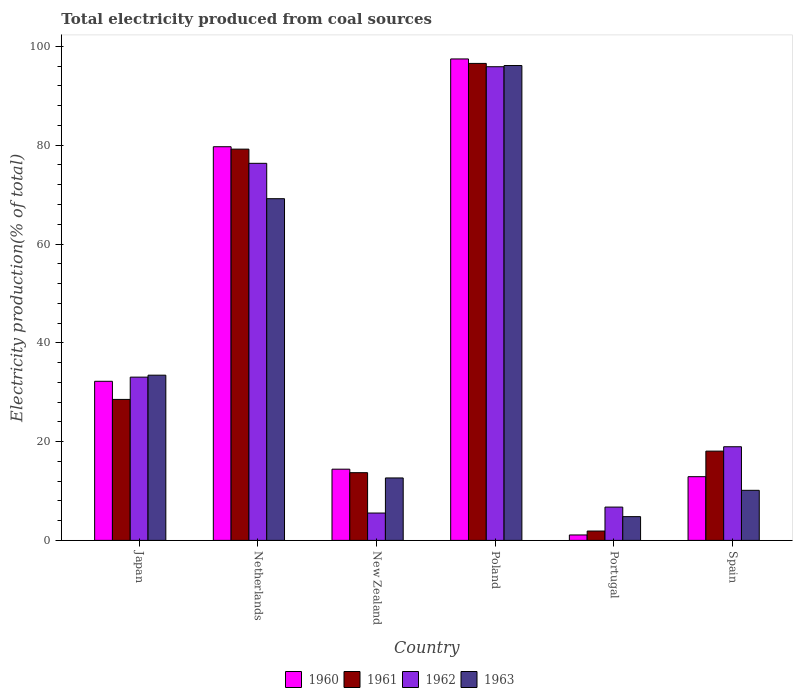How many groups of bars are there?
Offer a terse response. 6. Are the number of bars per tick equal to the number of legend labels?
Offer a terse response. Yes. What is the label of the 3rd group of bars from the left?
Make the answer very short. New Zealand. What is the total electricity produced in 1963 in Netherlands?
Provide a short and direct response. 69.17. Across all countries, what is the maximum total electricity produced in 1962?
Your response must be concise. 95.89. Across all countries, what is the minimum total electricity produced in 1960?
Ensure brevity in your answer.  1.1. In which country was the total electricity produced in 1961 maximum?
Offer a terse response. Poland. What is the total total electricity produced in 1962 in the graph?
Ensure brevity in your answer.  236.5. What is the difference between the total electricity produced in 1963 in Japan and that in Portugal?
Provide a short and direct response. 28.63. What is the difference between the total electricity produced in 1960 in Portugal and the total electricity produced in 1961 in Netherlands?
Provide a short and direct response. -78.11. What is the average total electricity produced in 1961 per country?
Provide a short and direct response. 39.66. What is the difference between the total electricity produced of/in 1962 and total electricity produced of/in 1963 in Portugal?
Make the answer very short. 1.93. What is the ratio of the total electricity produced in 1960 in Netherlands to that in Portugal?
Ensure brevity in your answer.  72.59. Is the difference between the total electricity produced in 1962 in Netherlands and Poland greater than the difference between the total electricity produced in 1963 in Netherlands and Poland?
Offer a very short reply. Yes. What is the difference between the highest and the second highest total electricity produced in 1963?
Offer a terse response. 62.69. What is the difference between the highest and the lowest total electricity produced in 1963?
Give a very brief answer. 91.32. Is the sum of the total electricity produced in 1961 in Portugal and Spain greater than the maximum total electricity produced in 1963 across all countries?
Offer a very short reply. No. What does the 1st bar from the left in Japan represents?
Make the answer very short. 1960. What does the 1st bar from the right in Netherlands represents?
Provide a short and direct response. 1963. Is it the case that in every country, the sum of the total electricity produced in 1963 and total electricity produced in 1960 is greater than the total electricity produced in 1962?
Provide a short and direct response. No. How many bars are there?
Provide a succinct answer. 24. Are all the bars in the graph horizontal?
Make the answer very short. No. What is the difference between two consecutive major ticks on the Y-axis?
Offer a very short reply. 20. Are the values on the major ticks of Y-axis written in scientific E-notation?
Give a very brief answer. No. Does the graph contain any zero values?
Provide a succinct answer. No. Does the graph contain grids?
Make the answer very short. No. How many legend labels are there?
Give a very brief answer. 4. How are the legend labels stacked?
Keep it short and to the point. Horizontal. What is the title of the graph?
Provide a short and direct response. Total electricity produced from coal sources. Does "1990" appear as one of the legend labels in the graph?
Ensure brevity in your answer.  No. What is the label or title of the X-axis?
Ensure brevity in your answer.  Country. What is the label or title of the Y-axis?
Your answer should be very brief. Electricity production(% of total). What is the Electricity production(% of total) in 1960 in Japan?
Offer a terse response. 32.21. What is the Electricity production(% of total) in 1961 in Japan?
Your answer should be compact. 28.54. What is the Electricity production(% of total) in 1962 in Japan?
Your response must be concise. 33.05. What is the Electricity production(% of total) in 1963 in Japan?
Give a very brief answer. 33.44. What is the Electricity production(% of total) in 1960 in Netherlands?
Keep it short and to the point. 79.69. What is the Electricity production(% of total) of 1961 in Netherlands?
Provide a short and direct response. 79.2. What is the Electricity production(% of total) of 1962 in Netherlands?
Offer a very short reply. 76.33. What is the Electricity production(% of total) of 1963 in Netherlands?
Provide a short and direct response. 69.17. What is the Electricity production(% of total) in 1960 in New Zealand?
Ensure brevity in your answer.  14.42. What is the Electricity production(% of total) in 1961 in New Zealand?
Your response must be concise. 13.71. What is the Electricity production(% of total) in 1962 in New Zealand?
Ensure brevity in your answer.  5.54. What is the Electricity production(% of total) in 1963 in New Zealand?
Keep it short and to the point. 12.64. What is the Electricity production(% of total) of 1960 in Poland?
Provide a short and direct response. 97.46. What is the Electricity production(% of total) in 1961 in Poland?
Offer a very short reply. 96.56. What is the Electricity production(% of total) of 1962 in Poland?
Ensure brevity in your answer.  95.89. What is the Electricity production(% of total) in 1963 in Poland?
Give a very brief answer. 96.13. What is the Electricity production(% of total) in 1960 in Portugal?
Keep it short and to the point. 1.1. What is the Electricity production(% of total) in 1961 in Portugal?
Provide a short and direct response. 1.89. What is the Electricity production(% of total) in 1962 in Portugal?
Ensure brevity in your answer.  6.74. What is the Electricity production(% of total) of 1963 in Portugal?
Make the answer very short. 4.81. What is the Electricity production(% of total) in 1960 in Spain?
Offer a terse response. 12.9. What is the Electricity production(% of total) of 1961 in Spain?
Your answer should be compact. 18.07. What is the Electricity production(% of total) in 1962 in Spain?
Provide a succinct answer. 18.96. What is the Electricity production(% of total) in 1963 in Spain?
Make the answer very short. 10.14. Across all countries, what is the maximum Electricity production(% of total) of 1960?
Your answer should be very brief. 97.46. Across all countries, what is the maximum Electricity production(% of total) in 1961?
Provide a succinct answer. 96.56. Across all countries, what is the maximum Electricity production(% of total) of 1962?
Keep it short and to the point. 95.89. Across all countries, what is the maximum Electricity production(% of total) in 1963?
Keep it short and to the point. 96.13. Across all countries, what is the minimum Electricity production(% of total) of 1960?
Your response must be concise. 1.1. Across all countries, what is the minimum Electricity production(% of total) in 1961?
Your answer should be compact. 1.89. Across all countries, what is the minimum Electricity production(% of total) in 1962?
Your response must be concise. 5.54. Across all countries, what is the minimum Electricity production(% of total) of 1963?
Keep it short and to the point. 4.81. What is the total Electricity production(% of total) in 1960 in the graph?
Ensure brevity in your answer.  237.78. What is the total Electricity production(% of total) of 1961 in the graph?
Your answer should be very brief. 237.98. What is the total Electricity production(% of total) of 1962 in the graph?
Keep it short and to the point. 236.5. What is the total Electricity production(% of total) in 1963 in the graph?
Your response must be concise. 226.33. What is the difference between the Electricity production(% of total) of 1960 in Japan and that in Netherlands?
Provide a short and direct response. -47.48. What is the difference between the Electricity production(% of total) in 1961 in Japan and that in Netherlands?
Your response must be concise. -50.67. What is the difference between the Electricity production(% of total) in 1962 in Japan and that in Netherlands?
Ensure brevity in your answer.  -43.28. What is the difference between the Electricity production(% of total) in 1963 in Japan and that in Netherlands?
Offer a terse response. -35.73. What is the difference between the Electricity production(% of total) of 1960 in Japan and that in New Zealand?
Provide a short and direct response. 17.79. What is the difference between the Electricity production(% of total) of 1961 in Japan and that in New Zealand?
Ensure brevity in your answer.  14.83. What is the difference between the Electricity production(% of total) in 1962 in Japan and that in New Zealand?
Offer a very short reply. 27.51. What is the difference between the Electricity production(% of total) of 1963 in Japan and that in New Zealand?
Your answer should be compact. 20.8. What is the difference between the Electricity production(% of total) in 1960 in Japan and that in Poland?
Your response must be concise. -65.25. What is the difference between the Electricity production(% of total) of 1961 in Japan and that in Poland?
Your response must be concise. -68.02. What is the difference between the Electricity production(% of total) of 1962 in Japan and that in Poland?
Your answer should be very brief. -62.84. What is the difference between the Electricity production(% of total) of 1963 in Japan and that in Poland?
Your response must be concise. -62.69. What is the difference between the Electricity production(% of total) of 1960 in Japan and that in Portugal?
Provide a short and direct response. 31.11. What is the difference between the Electricity production(% of total) of 1961 in Japan and that in Portugal?
Your answer should be compact. 26.64. What is the difference between the Electricity production(% of total) in 1962 in Japan and that in Portugal?
Give a very brief answer. 26.31. What is the difference between the Electricity production(% of total) of 1963 in Japan and that in Portugal?
Your answer should be very brief. 28.63. What is the difference between the Electricity production(% of total) of 1960 in Japan and that in Spain?
Give a very brief answer. 19.31. What is the difference between the Electricity production(% of total) in 1961 in Japan and that in Spain?
Ensure brevity in your answer.  10.47. What is the difference between the Electricity production(% of total) in 1962 in Japan and that in Spain?
Provide a short and direct response. 14.09. What is the difference between the Electricity production(% of total) of 1963 in Japan and that in Spain?
Keep it short and to the point. 23.31. What is the difference between the Electricity production(% of total) in 1960 in Netherlands and that in New Zealand?
Provide a succinct answer. 65.28. What is the difference between the Electricity production(% of total) of 1961 in Netherlands and that in New Zealand?
Ensure brevity in your answer.  65.5. What is the difference between the Electricity production(% of total) of 1962 in Netherlands and that in New Zealand?
Offer a terse response. 70.8. What is the difference between the Electricity production(% of total) in 1963 in Netherlands and that in New Zealand?
Provide a succinct answer. 56.53. What is the difference between the Electricity production(% of total) in 1960 in Netherlands and that in Poland?
Keep it short and to the point. -17.77. What is the difference between the Electricity production(% of total) in 1961 in Netherlands and that in Poland?
Provide a succinct answer. -17.35. What is the difference between the Electricity production(% of total) in 1962 in Netherlands and that in Poland?
Offer a very short reply. -19.56. What is the difference between the Electricity production(% of total) of 1963 in Netherlands and that in Poland?
Provide a short and direct response. -26.96. What is the difference between the Electricity production(% of total) in 1960 in Netherlands and that in Portugal?
Keep it short and to the point. 78.59. What is the difference between the Electricity production(% of total) in 1961 in Netherlands and that in Portugal?
Provide a short and direct response. 77.31. What is the difference between the Electricity production(% of total) of 1962 in Netherlands and that in Portugal?
Provide a short and direct response. 69.59. What is the difference between the Electricity production(% of total) in 1963 in Netherlands and that in Portugal?
Your answer should be compact. 64.36. What is the difference between the Electricity production(% of total) in 1960 in Netherlands and that in Spain?
Give a very brief answer. 66.79. What is the difference between the Electricity production(% of total) in 1961 in Netherlands and that in Spain?
Your answer should be compact. 61.13. What is the difference between the Electricity production(% of total) in 1962 in Netherlands and that in Spain?
Keep it short and to the point. 57.38. What is the difference between the Electricity production(% of total) in 1963 in Netherlands and that in Spain?
Offer a terse response. 59.04. What is the difference between the Electricity production(% of total) of 1960 in New Zealand and that in Poland?
Offer a very short reply. -83.05. What is the difference between the Electricity production(% of total) in 1961 in New Zealand and that in Poland?
Keep it short and to the point. -82.85. What is the difference between the Electricity production(% of total) of 1962 in New Zealand and that in Poland?
Give a very brief answer. -90.35. What is the difference between the Electricity production(% of total) in 1963 in New Zealand and that in Poland?
Provide a short and direct response. -83.49. What is the difference between the Electricity production(% of total) of 1960 in New Zealand and that in Portugal?
Offer a very short reply. 13.32. What is the difference between the Electricity production(% of total) in 1961 in New Zealand and that in Portugal?
Give a very brief answer. 11.81. What is the difference between the Electricity production(% of total) in 1962 in New Zealand and that in Portugal?
Make the answer very short. -1.2. What is the difference between the Electricity production(% of total) in 1963 in New Zealand and that in Portugal?
Ensure brevity in your answer.  7.83. What is the difference between the Electricity production(% of total) of 1960 in New Zealand and that in Spain?
Your answer should be compact. 1.52. What is the difference between the Electricity production(% of total) of 1961 in New Zealand and that in Spain?
Offer a terse response. -4.36. What is the difference between the Electricity production(% of total) of 1962 in New Zealand and that in Spain?
Your response must be concise. -13.42. What is the difference between the Electricity production(% of total) in 1963 in New Zealand and that in Spain?
Provide a short and direct response. 2.5. What is the difference between the Electricity production(% of total) in 1960 in Poland and that in Portugal?
Offer a very short reply. 96.36. What is the difference between the Electricity production(% of total) in 1961 in Poland and that in Portugal?
Make the answer very short. 94.66. What is the difference between the Electricity production(% of total) of 1962 in Poland and that in Portugal?
Make the answer very short. 89.15. What is the difference between the Electricity production(% of total) of 1963 in Poland and that in Portugal?
Give a very brief answer. 91.32. What is the difference between the Electricity production(% of total) of 1960 in Poland and that in Spain?
Provide a succinct answer. 84.56. What is the difference between the Electricity production(% of total) of 1961 in Poland and that in Spain?
Keep it short and to the point. 78.49. What is the difference between the Electricity production(% of total) of 1962 in Poland and that in Spain?
Offer a very short reply. 76.93. What is the difference between the Electricity production(% of total) of 1963 in Poland and that in Spain?
Keep it short and to the point. 86. What is the difference between the Electricity production(% of total) of 1960 in Portugal and that in Spain?
Keep it short and to the point. -11.8. What is the difference between the Electricity production(% of total) in 1961 in Portugal and that in Spain?
Offer a very short reply. -16.18. What is the difference between the Electricity production(% of total) of 1962 in Portugal and that in Spain?
Give a very brief answer. -12.22. What is the difference between the Electricity production(% of total) in 1963 in Portugal and that in Spain?
Provide a succinct answer. -5.33. What is the difference between the Electricity production(% of total) of 1960 in Japan and the Electricity production(% of total) of 1961 in Netherlands?
Your answer should be compact. -47. What is the difference between the Electricity production(% of total) of 1960 in Japan and the Electricity production(% of total) of 1962 in Netherlands?
Your response must be concise. -44.13. What is the difference between the Electricity production(% of total) in 1960 in Japan and the Electricity production(% of total) in 1963 in Netherlands?
Your answer should be compact. -36.96. What is the difference between the Electricity production(% of total) of 1961 in Japan and the Electricity production(% of total) of 1962 in Netherlands?
Your answer should be compact. -47.79. What is the difference between the Electricity production(% of total) in 1961 in Japan and the Electricity production(% of total) in 1963 in Netherlands?
Your answer should be very brief. -40.63. What is the difference between the Electricity production(% of total) of 1962 in Japan and the Electricity production(% of total) of 1963 in Netherlands?
Offer a very short reply. -36.12. What is the difference between the Electricity production(% of total) in 1960 in Japan and the Electricity production(% of total) in 1961 in New Zealand?
Provide a short and direct response. 18.5. What is the difference between the Electricity production(% of total) of 1960 in Japan and the Electricity production(% of total) of 1962 in New Zealand?
Ensure brevity in your answer.  26.67. What is the difference between the Electricity production(% of total) in 1960 in Japan and the Electricity production(% of total) in 1963 in New Zealand?
Your answer should be very brief. 19.57. What is the difference between the Electricity production(% of total) of 1961 in Japan and the Electricity production(% of total) of 1962 in New Zealand?
Ensure brevity in your answer.  23. What is the difference between the Electricity production(% of total) of 1961 in Japan and the Electricity production(% of total) of 1963 in New Zealand?
Your response must be concise. 15.9. What is the difference between the Electricity production(% of total) of 1962 in Japan and the Electricity production(% of total) of 1963 in New Zealand?
Keep it short and to the point. 20.41. What is the difference between the Electricity production(% of total) of 1960 in Japan and the Electricity production(% of total) of 1961 in Poland?
Keep it short and to the point. -64.35. What is the difference between the Electricity production(% of total) of 1960 in Japan and the Electricity production(% of total) of 1962 in Poland?
Make the answer very short. -63.68. What is the difference between the Electricity production(% of total) in 1960 in Japan and the Electricity production(% of total) in 1963 in Poland?
Give a very brief answer. -63.92. What is the difference between the Electricity production(% of total) of 1961 in Japan and the Electricity production(% of total) of 1962 in Poland?
Offer a very short reply. -67.35. What is the difference between the Electricity production(% of total) of 1961 in Japan and the Electricity production(% of total) of 1963 in Poland?
Provide a short and direct response. -67.59. What is the difference between the Electricity production(% of total) in 1962 in Japan and the Electricity production(% of total) in 1963 in Poland?
Keep it short and to the point. -63.08. What is the difference between the Electricity production(% of total) of 1960 in Japan and the Electricity production(% of total) of 1961 in Portugal?
Offer a very short reply. 30.31. What is the difference between the Electricity production(% of total) in 1960 in Japan and the Electricity production(% of total) in 1962 in Portugal?
Keep it short and to the point. 25.47. What is the difference between the Electricity production(% of total) in 1960 in Japan and the Electricity production(% of total) in 1963 in Portugal?
Your answer should be compact. 27.4. What is the difference between the Electricity production(% of total) in 1961 in Japan and the Electricity production(% of total) in 1962 in Portugal?
Ensure brevity in your answer.  21.8. What is the difference between the Electricity production(% of total) in 1961 in Japan and the Electricity production(% of total) in 1963 in Portugal?
Provide a succinct answer. 23.73. What is the difference between the Electricity production(% of total) of 1962 in Japan and the Electricity production(% of total) of 1963 in Portugal?
Provide a short and direct response. 28.24. What is the difference between the Electricity production(% of total) of 1960 in Japan and the Electricity production(% of total) of 1961 in Spain?
Ensure brevity in your answer.  14.14. What is the difference between the Electricity production(% of total) in 1960 in Japan and the Electricity production(% of total) in 1962 in Spain?
Ensure brevity in your answer.  13.25. What is the difference between the Electricity production(% of total) of 1960 in Japan and the Electricity production(% of total) of 1963 in Spain?
Offer a very short reply. 22.07. What is the difference between the Electricity production(% of total) of 1961 in Japan and the Electricity production(% of total) of 1962 in Spain?
Your answer should be compact. 9.58. What is the difference between the Electricity production(% of total) of 1961 in Japan and the Electricity production(% of total) of 1963 in Spain?
Ensure brevity in your answer.  18.4. What is the difference between the Electricity production(% of total) in 1962 in Japan and the Electricity production(% of total) in 1963 in Spain?
Make the answer very short. 22.91. What is the difference between the Electricity production(% of total) in 1960 in Netherlands and the Electricity production(% of total) in 1961 in New Zealand?
Your answer should be very brief. 65.98. What is the difference between the Electricity production(% of total) of 1960 in Netherlands and the Electricity production(% of total) of 1962 in New Zealand?
Offer a very short reply. 74.16. What is the difference between the Electricity production(% of total) of 1960 in Netherlands and the Electricity production(% of total) of 1963 in New Zealand?
Your answer should be compact. 67.05. What is the difference between the Electricity production(% of total) in 1961 in Netherlands and the Electricity production(% of total) in 1962 in New Zealand?
Keep it short and to the point. 73.67. What is the difference between the Electricity production(% of total) of 1961 in Netherlands and the Electricity production(% of total) of 1963 in New Zealand?
Keep it short and to the point. 66.56. What is the difference between the Electricity production(% of total) of 1962 in Netherlands and the Electricity production(% of total) of 1963 in New Zealand?
Offer a very short reply. 63.69. What is the difference between the Electricity production(% of total) in 1960 in Netherlands and the Electricity production(% of total) in 1961 in Poland?
Make the answer very short. -16.86. What is the difference between the Electricity production(% of total) of 1960 in Netherlands and the Electricity production(% of total) of 1962 in Poland?
Your answer should be compact. -16.2. What is the difference between the Electricity production(% of total) in 1960 in Netherlands and the Electricity production(% of total) in 1963 in Poland?
Your response must be concise. -16.44. What is the difference between the Electricity production(% of total) of 1961 in Netherlands and the Electricity production(% of total) of 1962 in Poland?
Make the answer very short. -16.68. What is the difference between the Electricity production(% of total) in 1961 in Netherlands and the Electricity production(% of total) in 1963 in Poland?
Keep it short and to the point. -16.93. What is the difference between the Electricity production(% of total) of 1962 in Netherlands and the Electricity production(% of total) of 1963 in Poland?
Your response must be concise. -19.8. What is the difference between the Electricity production(% of total) in 1960 in Netherlands and the Electricity production(% of total) in 1961 in Portugal?
Provide a succinct answer. 77.8. What is the difference between the Electricity production(% of total) of 1960 in Netherlands and the Electricity production(% of total) of 1962 in Portugal?
Provide a short and direct response. 72.95. What is the difference between the Electricity production(% of total) in 1960 in Netherlands and the Electricity production(% of total) in 1963 in Portugal?
Give a very brief answer. 74.88. What is the difference between the Electricity production(% of total) of 1961 in Netherlands and the Electricity production(% of total) of 1962 in Portugal?
Make the answer very short. 72.46. What is the difference between the Electricity production(% of total) in 1961 in Netherlands and the Electricity production(% of total) in 1963 in Portugal?
Give a very brief answer. 74.4. What is the difference between the Electricity production(% of total) of 1962 in Netherlands and the Electricity production(% of total) of 1963 in Portugal?
Give a very brief answer. 71.52. What is the difference between the Electricity production(% of total) in 1960 in Netherlands and the Electricity production(% of total) in 1961 in Spain?
Offer a terse response. 61.62. What is the difference between the Electricity production(% of total) in 1960 in Netherlands and the Electricity production(% of total) in 1962 in Spain?
Keep it short and to the point. 60.74. What is the difference between the Electricity production(% of total) in 1960 in Netherlands and the Electricity production(% of total) in 1963 in Spain?
Provide a succinct answer. 69.56. What is the difference between the Electricity production(% of total) of 1961 in Netherlands and the Electricity production(% of total) of 1962 in Spain?
Ensure brevity in your answer.  60.25. What is the difference between the Electricity production(% of total) of 1961 in Netherlands and the Electricity production(% of total) of 1963 in Spain?
Make the answer very short. 69.07. What is the difference between the Electricity production(% of total) of 1962 in Netherlands and the Electricity production(% of total) of 1963 in Spain?
Provide a succinct answer. 66.2. What is the difference between the Electricity production(% of total) in 1960 in New Zealand and the Electricity production(% of total) in 1961 in Poland?
Keep it short and to the point. -82.14. What is the difference between the Electricity production(% of total) in 1960 in New Zealand and the Electricity production(% of total) in 1962 in Poland?
Give a very brief answer. -81.47. What is the difference between the Electricity production(% of total) in 1960 in New Zealand and the Electricity production(% of total) in 1963 in Poland?
Offer a terse response. -81.71. What is the difference between the Electricity production(% of total) of 1961 in New Zealand and the Electricity production(% of total) of 1962 in Poland?
Offer a terse response. -82.18. What is the difference between the Electricity production(% of total) in 1961 in New Zealand and the Electricity production(% of total) in 1963 in Poland?
Provide a short and direct response. -82.42. What is the difference between the Electricity production(% of total) in 1962 in New Zealand and the Electricity production(% of total) in 1963 in Poland?
Provide a short and direct response. -90.6. What is the difference between the Electricity production(% of total) of 1960 in New Zealand and the Electricity production(% of total) of 1961 in Portugal?
Give a very brief answer. 12.52. What is the difference between the Electricity production(% of total) of 1960 in New Zealand and the Electricity production(% of total) of 1962 in Portugal?
Your answer should be very brief. 7.68. What is the difference between the Electricity production(% of total) in 1960 in New Zealand and the Electricity production(% of total) in 1963 in Portugal?
Provide a short and direct response. 9.61. What is the difference between the Electricity production(% of total) of 1961 in New Zealand and the Electricity production(% of total) of 1962 in Portugal?
Your response must be concise. 6.97. What is the difference between the Electricity production(% of total) in 1961 in New Zealand and the Electricity production(% of total) in 1963 in Portugal?
Your answer should be compact. 8.9. What is the difference between the Electricity production(% of total) in 1962 in New Zealand and the Electricity production(% of total) in 1963 in Portugal?
Your answer should be very brief. 0.73. What is the difference between the Electricity production(% of total) in 1960 in New Zealand and the Electricity production(% of total) in 1961 in Spain?
Provide a short and direct response. -3.65. What is the difference between the Electricity production(% of total) in 1960 in New Zealand and the Electricity production(% of total) in 1962 in Spain?
Provide a short and direct response. -4.54. What is the difference between the Electricity production(% of total) of 1960 in New Zealand and the Electricity production(% of total) of 1963 in Spain?
Your answer should be compact. 4.28. What is the difference between the Electricity production(% of total) in 1961 in New Zealand and the Electricity production(% of total) in 1962 in Spain?
Provide a short and direct response. -5.25. What is the difference between the Electricity production(% of total) in 1961 in New Zealand and the Electricity production(% of total) in 1963 in Spain?
Provide a succinct answer. 3.57. What is the difference between the Electricity production(% of total) of 1962 in New Zealand and the Electricity production(% of total) of 1963 in Spain?
Your answer should be very brief. -4.6. What is the difference between the Electricity production(% of total) of 1960 in Poland and the Electricity production(% of total) of 1961 in Portugal?
Your answer should be compact. 95.57. What is the difference between the Electricity production(% of total) of 1960 in Poland and the Electricity production(% of total) of 1962 in Portugal?
Make the answer very short. 90.72. What is the difference between the Electricity production(% of total) in 1960 in Poland and the Electricity production(% of total) in 1963 in Portugal?
Offer a very short reply. 92.65. What is the difference between the Electricity production(% of total) in 1961 in Poland and the Electricity production(% of total) in 1962 in Portugal?
Make the answer very short. 89.82. What is the difference between the Electricity production(% of total) in 1961 in Poland and the Electricity production(% of total) in 1963 in Portugal?
Keep it short and to the point. 91.75. What is the difference between the Electricity production(% of total) in 1962 in Poland and the Electricity production(% of total) in 1963 in Portugal?
Your answer should be compact. 91.08. What is the difference between the Electricity production(% of total) of 1960 in Poland and the Electricity production(% of total) of 1961 in Spain?
Make the answer very short. 79.39. What is the difference between the Electricity production(% of total) in 1960 in Poland and the Electricity production(% of total) in 1962 in Spain?
Your response must be concise. 78.51. What is the difference between the Electricity production(% of total) of 1960 in Poland and the Electricity production(% of total) of 1963 in Spain?
Your answer should be compact. 87.33. What is the difference between the Electricity production(% of total) in 1961 in Poland and the Electricity production(% of total) in 1962 in Spain?
Offer a very short reply. 77.6. What is the difference between the Electricity production(% of total) in 1961 in Poland and the Electricity production(% of total) in 1963 in Spain?
Make the answer very short. 86.42. What is the difference between the Electricity production(% of total) in 1962 in Poland and the Electricity production(% of total) in 1963 in Spain?
Keep it short and to the point. 85.75. What is the difference between the Electricity production(% of total) of 1960 in Portugal and the Electricity production(% of total) of 1961 in Spain?
Your answer should be compact. -16.97. What is the difference between the Electricity production(% of total) of 1960 in Portugal and the Electricity production(% of total) of 1962 in Spain?
Offer a terse response. -17.86. What is the difference between the Electricity production(% of total) of 1960 in Portugal and the Electricity production(% of total) of 1963 in Spain?
Ensure brevity in your answer.  -9.04. What is the difference between the Electricity production(% of total) in 1961 in Portugal and the Electricity production(% of total) in 1962 in Spain?
Provide a short and direct response. -17.06. What is the difference between the Electricity production(% of total) of 1961 in Portugal and the Electricity production(% of total) of 1963 in Spain?
Your answer should be very brief. -8.24. What is the difference between the Electricity production(% of total) of 1962 in Portugal and the Electricity production(% of total) of 1963 in Spain?
Give a very brief answer. -3.4. What is the average Electricity production(% of total) in 1960 per country?
Your response must be concise. 39.63. What is the average Electricity production(% of total) in 1961 per country?
Make the answer very short. 39.66. What is the average Electricity production(% of total) of 1962 per country?
Your answer should be very brief. 39.42. What is the average Electricity production(% of total) in 1963 per country?
Ensure brevity in your answer.  37.72. What is the difference between the Electricity production(% of total) of 1960 and Electricity production(% of total) of 1961 in Japan?
Provide a succinct answer. 3.67. What is the difference between the Electricity production(% of total) of 1960 and Electricity production(% of total) of 1962 in Japan?
Keep it short and to the point. -0.84. What is the difference between the Electricity production(% of total) in 1960 and Electricity production(% of total) in 1963 in Japan?
Provide a short and direct response. -1.24. What is the difference between the Electricity production(% of total) in 1961 and Electricity production(% of total) in 1962 in Japan?
Offer a very short reply. -4.51. What is the difference between the Electricity production(% of total) of 1961 and Electricity production(% of total) of 1963 in Japan?
Keep it short and to the point. -4.9. What is the difference between the Electricity production(% of total) in 1962 and Electricity production(% of total) in 1963 in Japan?
Your response must be concise. -0.4. What is the difference between the Electricity production(% of total) in 1960 and Electricity production(% of total) in 1961 in Netherlands?
Make the answer very short. 0.49. What is the difference between the Electricity production(% of total) in 1960 and Electricity production(% of total) in 1962 in Netherlands?
Give a very brief answer. 3.36. What is the difference between the Electricity production(% of total) of 1960 and Electricity production(% of total) of 1963 in Netherlands?
Provide a succinct answer. 10.52. What is the difference between the Electricity production(% of total) in 1961 and Electricity production(% of total) in 1962 in Netherlands?
Provide a succinct answer. 2.87. What is the difference between the Electricity production(% of total) in 1961 and Electricity production(% of total) in 1963 in Netherlands?
Offer a terse response. 10.03. What is the difference between the Electricity production(% of total) in 1962 and Electricity production(% of total) in 1963 in Netherlands?
Give a very brief answer. 7.16. What is the difference between the Electricity production(% of total) in 1960 and Electricity production(% of total) in 1961 in New Zealand?
Your response must be concise. 0.71. What is the difference between the Electricity production(% of total) in 1960 and Electricity production(% of total) in 1962 in New Zealand?
Your answer should be compact. 8.88. What is the difference between the Electricity production(% of total) in 1960 and Electricity production(% of total) in 1963 in New Zealand?
Provide a short and direct response. 1.78. What is the difference between the Electricity production(% of total) in 1961 and Electricity production(% of total) in 1962 in New Zealand?
Make the answer very short. 8.17. What is the difference between the Electricity production(% of total) of 1961 and Electricity production(% of total) of 1963 in New Zealand?
Give a very brief answer. 1.07. What is the difference between the Electricity production(% of total) of 1962 and Electricity production(% of total) of 1963 in New Zealand?
Offer a terse response. -7.1. What is the difference between the Electricity production(% of total) of 1960 and Electricity production(% of total) of 1961 in Poland?
Keep it short and to the point. 0.91. What is the difference between the Electricity production(% of total) of 1960 and Electricity production(% of total) of 1962 in Poland?
Your answer should be compact. 1.57. What is the difference between the Electricity production(% of total) of 1960 and Electricity production(% of total) of 1963 in Poland?
Ensure brevity in your answer.  1.33. What is the difference between the Electricity production(% of total) in 1961 and Electricity production(% of total) in 1962 in Poland?
Offer a very short reply. 0.67. What is the difference between the Electricity production(% of total) of 1961 and Electricity production(% of total) of 1963 in Poland?
Give a very brief answer. 0.43. What is the difference between the Electricity production(% of total) of 1962 and Electricity production(% of total) of 1963 in Poland?
Your answer should be very brief. -0.24. What is the difference between the Electricity production(% of total) in 1960 and Electricity production(% of total) in 1961 in Portugal?
Ensure brevity in your answer.  -0.8. What is the difference between the Electricity production(% of total) in 1960 and Electricity production(% of total) in 1962 in Portugal?
Offer a very short reply. -5.64. What is the difference between the Electricity production(% of total) in 1960 and Electricity production(% of total) in 1963 in Portugal?
Keep it short and to the point. -3.71. What is the difference between the Electricity production(% of total) of 1961 and Electricity production(% of total) of 1962 in Portugal?
Ensure brevity in your answer.  -4.85. What is the difference between the Electricity production(% of total) of 1961 and Electricity production(% of total) of 1963 in Portugal?
Give a very brief answer. -2.91. What is the difference between the Electricity production(% of total) in 1962 and Electricity production(% of total) in 1963 in Portugal?
Ensure brevity in your answer.  1.93. What is the difference between the Electricity production(% of total) in 1960 and Electricity production(% of total) in 1961 in Spain?
Keep it short and to the point. -5.17. What is the difference between the Electricity production(% of total) of 1960 and Electricity production(% of total) of 1962 in Spain?
Offer a terse response. -6.06. What is the difference between the Electricity production(% of total) of 1960 and Electricity production(% of total) of 1963 in Spain?
Provide a short and direct response. 2.76. What is the difference between the Electricity production(% of total) of 1961 and Electricity production(% of total) of 1962 in Spain?
Keep it short and to the point. -0.88. What is the difference between the Electricity production(% of total) of 1961 and Electricity production(% of total) of 1963 in Spain?
Provide a short and direct response. 7.94. What is the difference between the Electricity production(% of total) in 1962 and Electricity production(% of total) in 1963 in Spain?
Offer a terse response. 8.82. What is the ratio of the Electricity production(% of total) of 1960 in Japan to that in Netherlands?
Ensure brevity in your answer.  0.4. What is the ratio of the Electricity production(% of total) in 1961 in Japan to that in Netherlands?
Your response must be concise. 0.36. What is the ratio of the Electricity production(% of total) of 1962 in Japan to that in Netherlands?
Offer a very short reply. 0.43. What is the ratio of the Electricity production(% of total) in 1963 in Japan to that in Netherlands?
Give a very brief answer. 0.48. What is the ratio of the Electricity production(% of total) of 1960 in Japan to that in New Zealand?
Your response must be concise. 2.23. What is the ratio of the Electricity production(% of total) in 1961 in Japan to that in New Zealand?
Keep it short and to the point. 2.08. What is the ratio of the Electricity production(% of total) of 1962 in Japan to that in New Zealand?
Your answer should be very brief. 5.97. What is the ratio of the Electricity production(% of total) in 1963 in Japan to that in New Zealand?
Keep it short and to the point. 2.65. What is the ratio of the Electricity production(% of total) in 1960 in Japan to that in Poland?
Ensure brevity in your answer.  0.33. What is the ratio of the Electricity production(% of total) in 1961 in Japan to that in Poland?
Offer a very short reply. 0.3. What is the ratio of the Electricity production(% of total) of 1962 in Japan to that in Poland?
Keep it short and to the point. 0.34. What is the ratio of the Electricity production(% of total) in 1963 in Japan to that in Poland?
Your answer should be very brief. 0.35. What is the ratio of the Electricity production(% of total) of 1960 in Japan to that in Portugal?
Your answer should be compact. 29.34. What is the ratio of the Electricity production(% of total) of 1961 in Japan to that in Portugal?
Make the answer very short. 15.06. What is the ratio of the Electricity production(% of total) of 1962 in Japan to that in Portugal?
Make the answer very short. 4.9. What is the ratio of the Electricity production(% of total) of 1963 in Japan to that in Portugal?
Ensure brevity in your answer.  6.95. What is the ratio of the Electricity production(% of total) in 1960 in Japan to that in Spain?
Provide a short and direct response. 2.5. What is the ratio of the Electricity production(% of total) in 1961 in Japan to that in Spain?
Offer a terse response. 1.58. What is the ratio of the Electricity production(% of total) in 1962 in Japan to that in Spain?
Offer a very short reply. 1.74. What is the ratio of the Electricity production(% of total) of 1963 in Japan to that in Spain?
Make the answer very short. 3.3. What is the ratio of the Electricity production(% of total) of 1960 in Netherlands to that in New Zealand?
Offer a terse response. 5.53. What is the ratio of the Electricity production(% of total) in 1961 in Netherlands to that in New Zealand?
Ensure brevity in your answer.  5.78. What is the ratio of the Electricity production(% of total) in 1962 in Netherlands to that in New Zealand?
Give a very brief answer. 13.79. What is the ratio of the Electricity production(% of total) of 1963 in Netherlands to that in New Zealand?
Keep it short and to the point. 5.47. What is the ratio of the Electricity production(% of total) in 1960 in Netherlands to that in Poland?
Give a very brief answer. 0.82. What is the ratio of the Electricity production(% of total) of 1961 in Netherlands to that in Poland?
Ensure brevity in your answer.  0.82. What is the ratio of the Electricity production(% of total) of 1962 in Netherlands to that in Poland?
Provide a short and direct response. 0.8. What is the ratio of the Electricity production(% of total) in 1963 in Netherlands to that in Poland?
Provide a short and direct response. 0.72. What is the ratio of the Electricity production(% of total) of 1960 in Netherlands to that in Portugal?
Your answer should be very brief. 72.59. What is the ratio of the Electricity production(% of total) of 1961 in Netherlands to that in Portugal?
Offer a very short reply. 41.81. What is the ratio of the Electricity production(% of total) in 1962 in Netherlands to that in Portugal?
Offer a terse response. 11.32. What is the ratio of the Electricity production(% of total) in 1963 in Netherlands to that in Portugal?
Offer a terse response. 14.38. What is the ratio of the Electricity production(% of total) in 1960 in Netherlands to that in Spain?
Offer a terse response. 6.18. What is the ratio of the Electricity production(% of total) in 1961 in Netherlands to that in Spain?
Give a very brief answer. 4.38. What is the ratio of the Electricity production(% of total) of 1962 in Netherlands to that in Spain?
Your response must be concise. 4.03. What is the ratio of the Electricity production(% of total) of 1963 in Netherlands to that in Spain?
Your response must be concise. 6.82. What is the ratio of the Electricity production(% of total) in 1960 in New Zealand to that in Poland?
Your answer should be very brief. 0.15. What is the ratio of the Electricity production(% of total) of 1961 in New Zealand to that in Poland?
Your response must be concise. 0.14. What is the ratio of the Electricity production(% of total) of 1962 in New Zealand to that in Poland?
Provide a succinct answer. 0.06. What is the ratio of the Electricity production(% of total) of 1963 in New Zealand to that in Poland?
Your response must be concise. 0.13. What is the ratio of the Electricity production(% of total) in 1960 in New Zealand to that in Portugal?
Your answer should be very brief. 13.13. What is the ratio of the Electricity production(% of total) in 1961 in New Zealand to that in Portugal?
Provide a short and direct response. 7.24. What is the ratio of the Electricity production(% of total) in 1962 in New Zealand to that in Portugal?
Provide a succinct answer. 0.82. What is the ratio of the Electricity production(% of total) of 1963 in New Zealand to that in Portugal?
Your answer should be very brief. 2.63. What is the ratio of the Electricity production(% of total) in 1960 in New Zealand to that in Spain?
Offer a very short reply. 1.12. What is the ratio of the Electricity production(% of total) of 1961 in New Zealand to that in Spain?
Offer a very short reply. 0.76. What is the ratio of the Electricity production(% of total) of 1962 in New Zealand to that in Spain?
Provide a succinct answer. 0.29. What is the ratio of the Electricity production(% of total) of 1963 in New Zealand to that in Spain?
Keep it short and to the point. 1.25. What is the ratio of the Electricity production(% of total) in 1960 in Poland to that in Portugal?
Keep it short and to the point. 88.77. What is the ratio of the Electricity production(% of total) in 1961 in Poland to that in Portugal?
Your answer should be compact. 50.97. What is the ratio of the Electricity production(% of total) in 1962 in Poland to that in Portugal?
Provide a short and direct response. 14.23. What is the ratio of the Electricity production(% of total) of 1963 in Poland to that in Portugal?
Provide a short and direct response. 19.99. What is the ratio of the Electricity production(% of total) in 1960 in Poland to that in Spain?
Ensure brevity in your answer.  7.56. What is the ratio of the Electricity production(% of total) of 1961 in Poland to that in Spain?
Your response must be concise. 5.34. What is the ratio of the Electricity production(% of total) in 1962 in Poland to that in Spain?
Your response must be concise. 5.06. What is the ratio of the Electricity production(% of total) in 1963 in Poland to that in Spain?
Your response must be concise. 9.48. What is the ratio of the Electricity production(% of total) in 1960 in Portugal to that in Spain?
Make the answer very short. 0.09. What is the ratio of the Electricity production(% of total) in 1961 in Portugal to that in Spain?
Offer a terse response. 0.1. What is the ratio of the Electricity production(% of total) in 1962 in Portugal to that in Spain?
Provide a short and direct response. 0.36. What is the ratio of the Electricity production(% of total) in 1963 in Portugal to that in Spain?
Your answer should be very brief. 0.47. What is the difference between the highest and the second highest Electricity production(% of total) in 1960?
Make the answer very short. 17.77. What is the difference between the highest and the second highest Electricity production(% of total) of 1961?
Provide a short and direct response. 17.35. What is the difference between the highest and the second highest Electricity production(% of total) of 1962?
Provide a succinct answer. 19.56. What is the difference between the highest and the second highest Electricity production(% of total) in 1963?
Your response must be concise. 26.96. What is the difference between the highest and the lowest Electricity production(% of total) in 1960?
Provide a succinct answer. 96.36. What is the difference between the highest and the lowest Electricity production(% of total) of 1961?
Offer a terse response. 94.66. What is the difference between the highest and the lowest Electricity production(% of total) in 1962?
Offer a terse response. 90.35. What is the difference between the highest and the lowest Electricity production(% of total) of 1963?
Ensure brevity in your answer.  91.32. 